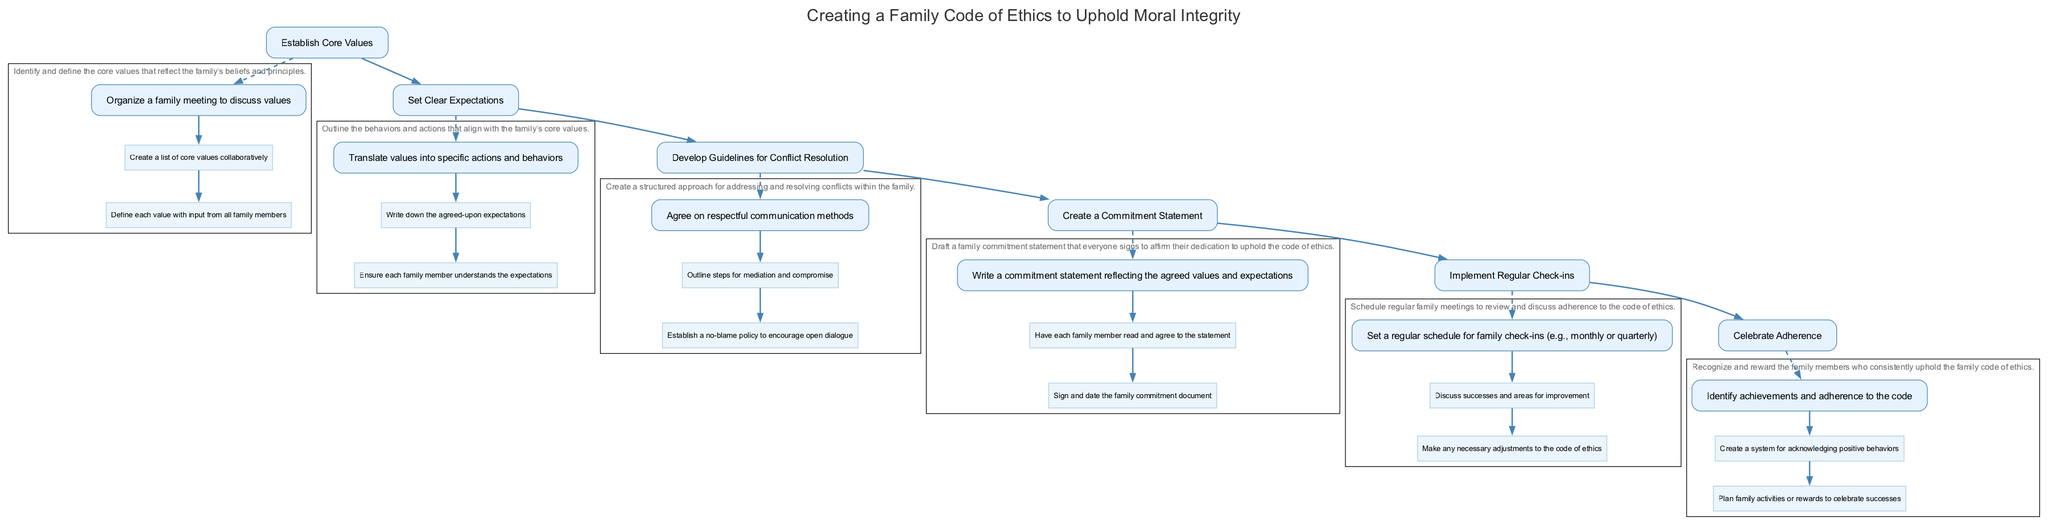What is the first step in creating a family code of ethics? The diagram indicates that the first step is to "Establish Core Values," as it is the initial element listed in the flow.
Answer: Establish Core Values How many main elements are there in the diagram? By counting the distinct elements provided in the diagram, there are a total of six main elements.
Answer: 6 What follows after developing guidelines for conflict resolution? Looking at the flow of the diagram, the element that comes after "Develop Guidelines for Conflict Resolution" is the "Create a Commitment Statement."
Answer: Create a Commitment Statement What is a key aspect of the commitment statement? The commitment statement reflects the agreed values and expectations, as noted in the description of the relevant element.
Answer: Agreed values and expectations What type of policy is established for conflict resolution? The diagram specifies that a "no-blame policy" is established to encourage open dialogue during conflict resolution.
Answer: No-blame policy During regular check-ins, what do family members discuss? The elements indicate that family members discuss "successes and areas for improvement" during the regular check-ins to review adherence.
Answer: Successes and areas for improvement What is the purpose of celebrating adherence? The purpose of celebrating adherence is to recognize and reward family members who consistently uphold the family code of ethics.
Answer: Recognize and reward Which element is structured as an ongoing process? In the diagram, "Implement Regular Check-ins" is designed as an ongoing process to ensure continuous engagement with the family code of ethics.
Answer: Implement Regular Check-ins 